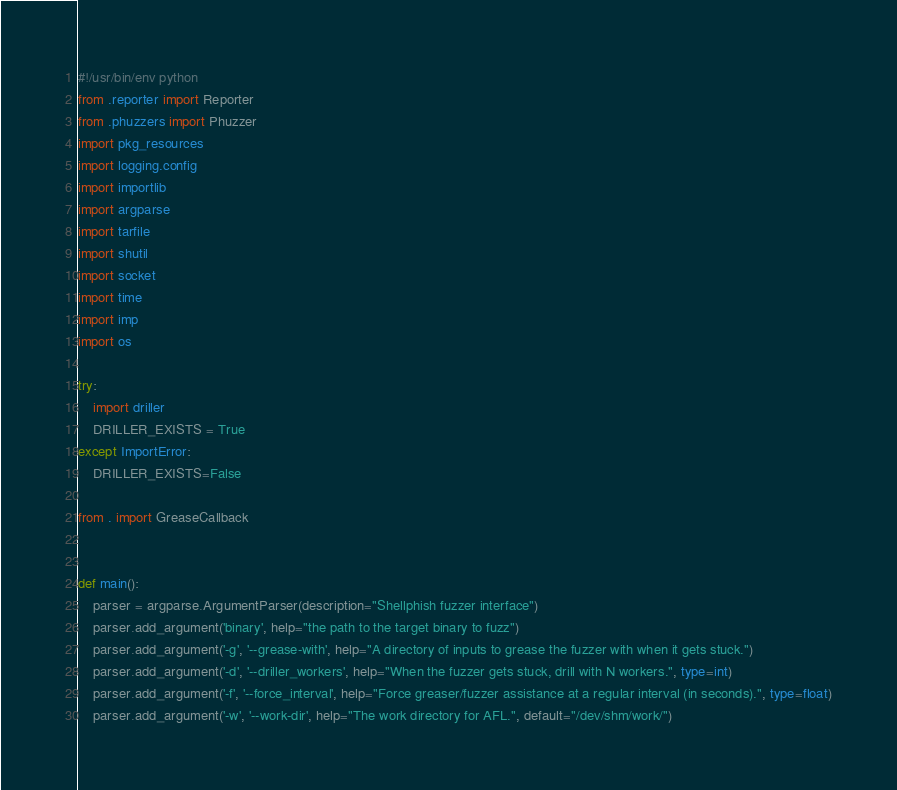<code> <loc_0><loc_0><loc_500><loc_500><_Python_>#!/usr/bin/env python
from .reporter import Reporter
from .phuzzers import Phuzzer
import pkg_resources
import logging.config
import importlib
import argparse
import tarfile
import shutil
import socket
import time
import imp
import os

try:
    import driller
    DRILLER_EXISTS = True
except ImportError:
    DRILLER_EXISTS=False

from . import GreaseCallback


def main():
    parser = argparse.ArgumentParser(description="Shellphish fuzzer interface")
    parser.add_argument('binary', help="the path to the target binary to fuzz")
    parser.add_argument('-g', '--grease-with', help="A directory of inputs to grease the fuzzer with when it gets stuck.")
    parser.add_argument('-d', '--driller_workers', help="When the fuzzer gets stuck, drill with N workers.", type=int)
    parser.add_argument('-f', '--force_interval', help="Force greaser/fuzzer assistance at a regular interval (in seconds).", type=float)
    parser.add_argument('-w', '--work-dir', help="The work directory for AFL.", default="/dev/shm/work/")
</code> 